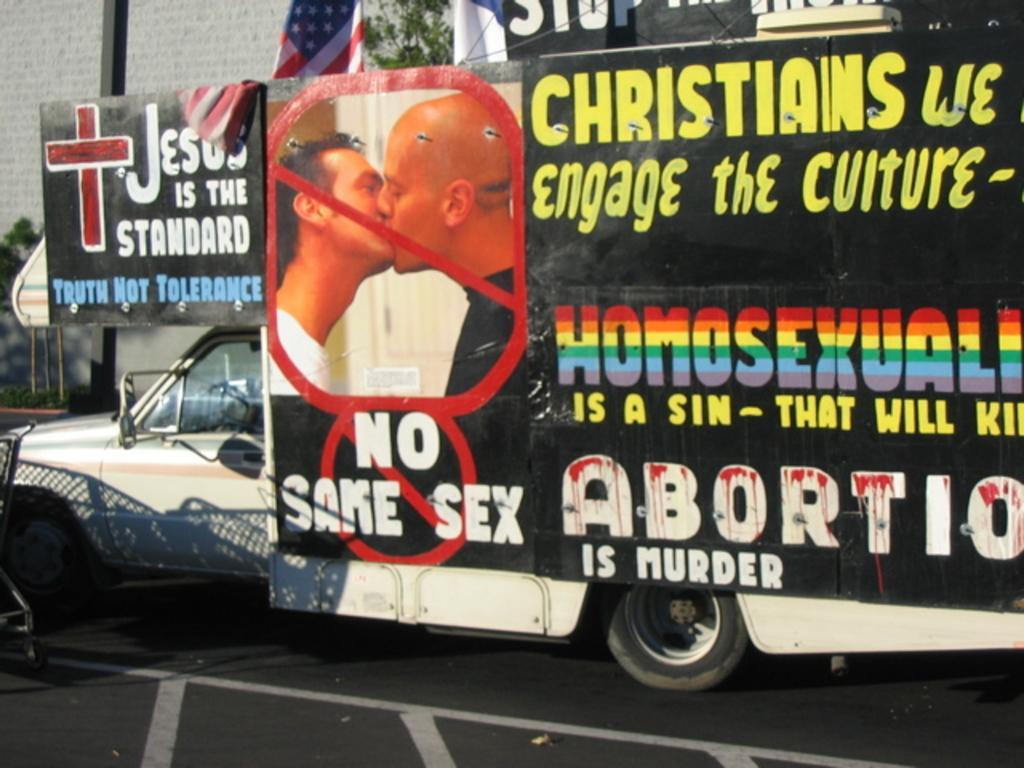Please provide a concise description of this image. In this image I can see a banner is attached to the vehicle. Back I can see trees,flag and building. 